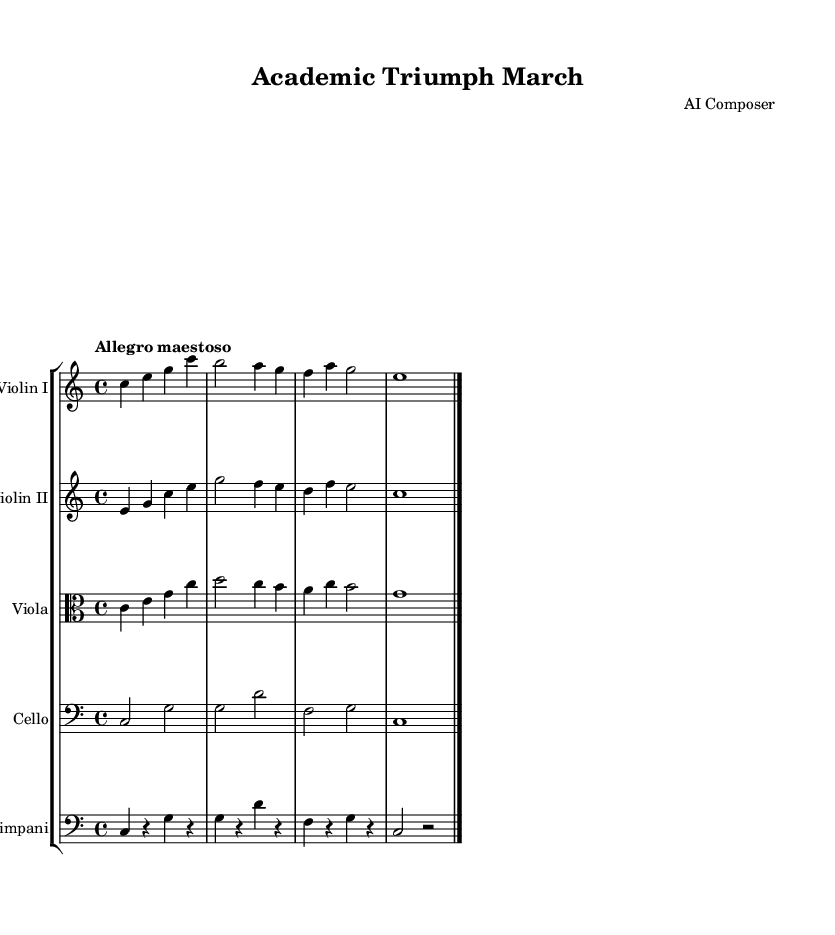What is the key signature of this music? The key signature shown in the music indicates that it is in C major, which is known for having no sharps or flats. You can confirm this by looking at the key signature at the beginning of the piece.
Answer: C major What is the time signature of this piece? The time signature is displayed at the beginning of the score, indicating the rhythm structure. In this case, it is 4/4, which means there are four beats in each measure and each quarter note gets one beat.
Answer: 4/4 What is the tempo marking of this music? The tempo marking is presented as "Allegro maestoso," which signifies a brisk and majestic tempo. This can be found typically above the staff where tempo indications are placed.
Answer: Allegro maestoso How many instruments are in this orchestration? By examining the score, you can see there are five unique staves representing different instrumental parts: Violin I, Violin II, Viola, Cello, and Timpani. Counting these gives the total number of instruments utilized in this orchestration.
Answer: Five Which instrument plays the bass clef? The Cello part is indicated with a bass clef, which designates it as the instrument that reads notes in the bass clef range. This can be identified by the clef symbol at the beginning of the Cello staff.
Answer: Cello Which staff group contains the violin parts? The staff group contains two staves labeled as "Violin I" and "Violin II," indicating they are the violin sections within the orchestral arrangement. You can tell because these are the first two staves listed in the score.
Answer: Violin I and Violin II 